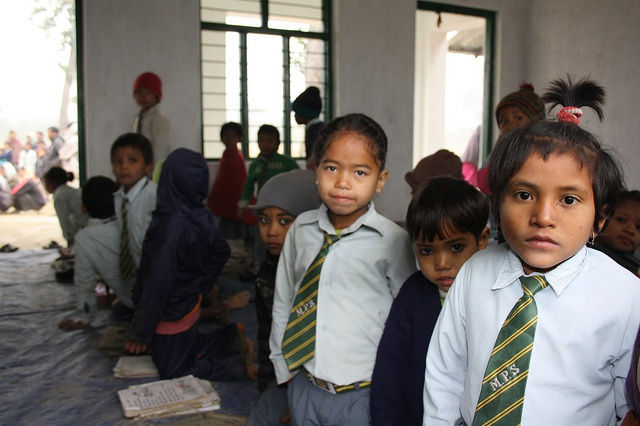Describe the objects in this image and their specific colors. I can see people in white, lavender, black, darkgray, and gray tones, people in white, darkgray, gray, lightgray, and black tones, people in white, black, maroon, gray, and darkgreen tones, people in white, black, maroon, and gray tones, and people in white, black, darkgray, and gray tones in this image. 